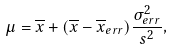<formula> <loc_0><loc_0><loc_500><loc_500>\mu = \overline { x } + ( \overline { x } - \overline { x } _ { e r r } ) \frac { \sigma _ { e r r } ^ { 2 } } { s ^ { 2 } } ,</formula> 